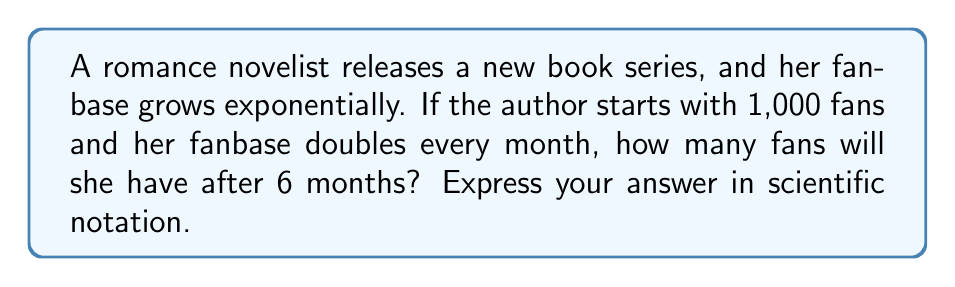What is the answer to this math problem? Let's approach this step-by-step:

1) The initial number of fans is 1,000.

2) The growth is exponential, doubling every month. We can represent this with the equation:

   $$F(t) = 1000 \cdot 2^t$$

   Where $F(t)$ is the number of fans after $t$ months.

3) We want to know the number of fans after 6 months, so we substitute $t = 6$:

   $$F(6) = 1000 \cdot 2^6$$

4) Let's calculate $2^6$:
   
   $$2^6 = 2 \cdot 2 \cdot 2 \cdot 2 \cdot 2 \cdot 2 = 64$$

5) Now we can multiply:

   $$F(6) = 1000 \cdot 64 = 64,000$$

6) To express this in scientific notation, we move the decimal point 4 places to the left:

   $$64,000 = 6.4 \times 10^4$$

Thus, after 6 months, the author will have $6.4 \times 10^4$ fans.
Answer: $6.4 \times 10^4$ 